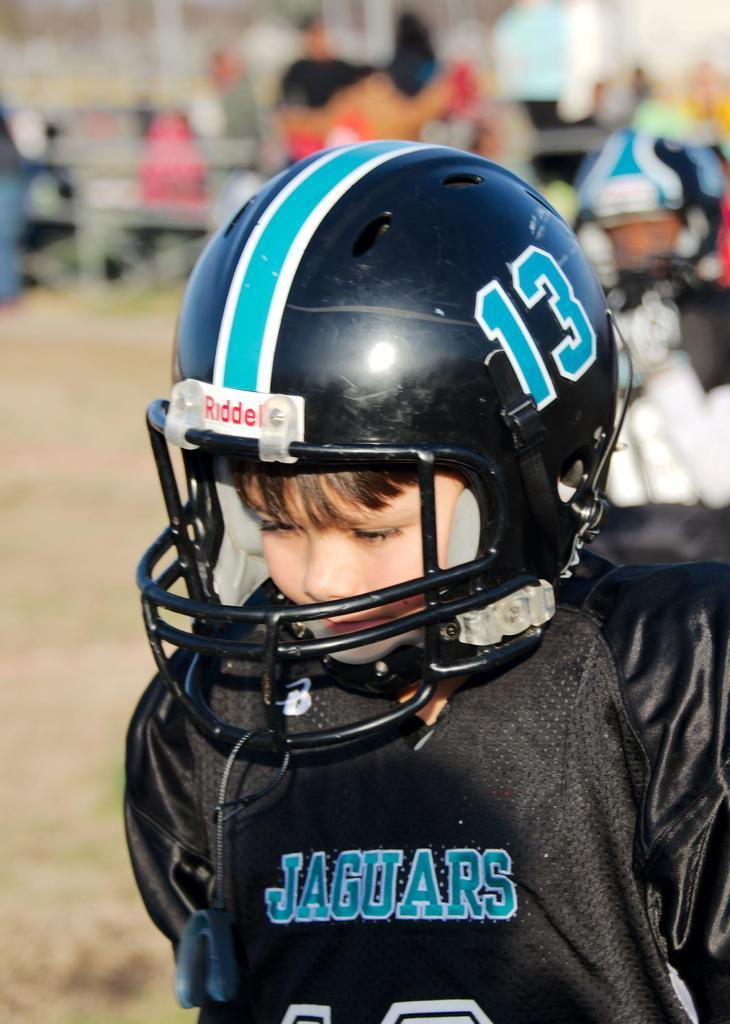Where are the people located in the image? The people are towards the right bottom of the image. What are the two people wearing? The two people are wearing helmets. What are the two people doing in the image? The two people are playing. What type of surface can be seen in the image? There is a ground visible in the image. What type of string can be seen tied to the flower in the image? There is no flower or string present in the image. Where is the sink located in the image? There is no sink present in the image. 